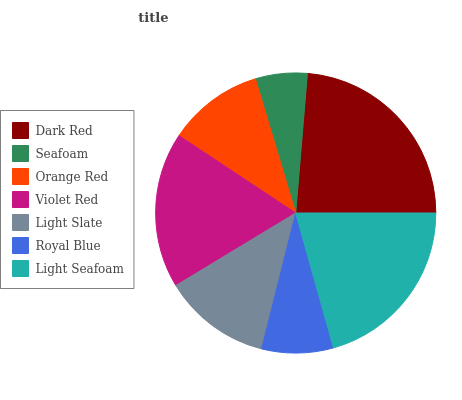Is Seafoam the minimum?
Answer yes or no. Yes. Is Dark Red the maximum?
Answer yes or no. Yes. Is Orange Red the minimum?
Answer yes or no. No. Is Orange Red the maximum?
Answer yes or no. No. Is Orange Red greater than Seafoam?
Answer yes or no. Yes. Is Seafoam less than Orange Red?
Answer yes or no. Yes. Is Seafoam greater than Orange Red?
Answer yes or no. No. Is Orange Red less than Seafoam?
Answer yes or no. No. Is Light Slate the high median?
Answer yes or no. Yes. Is Light Slate the low median?
Answer yes or no. Yes. Is Light Seafoam the high median?
Answer yes or no. No. Is Light Seafoam the low median?
Answer yes or no. No. 